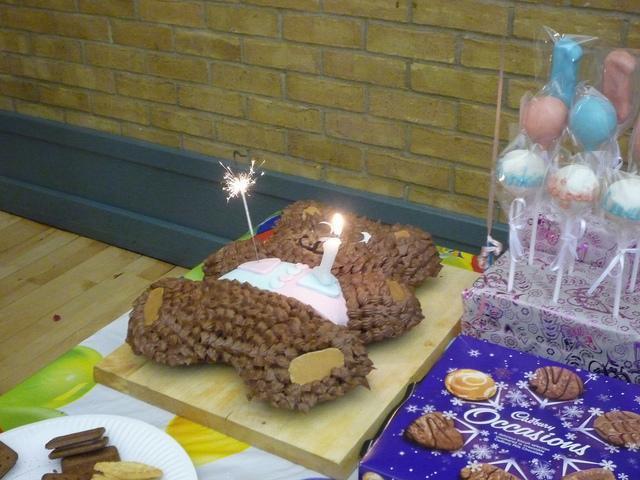Is the caption "The cake is below the teddy bear." a true representation of the image?
Answer yes or no. No. Does the caption "The teddy bear is toward the cake." correctly depict the image?
Answer yes or no. No. Is the caption "The teddy bear is on top of the cake." a true representation of the image?
Answer yes or no. No. Is the caption "The teddy bear is perpendicular to the dining table." a true representation of the image?
Answer yes or no. No. Evaluate: Does the caption "The cake is under the teddy bear." match the image?
Answer yes or no. No. 